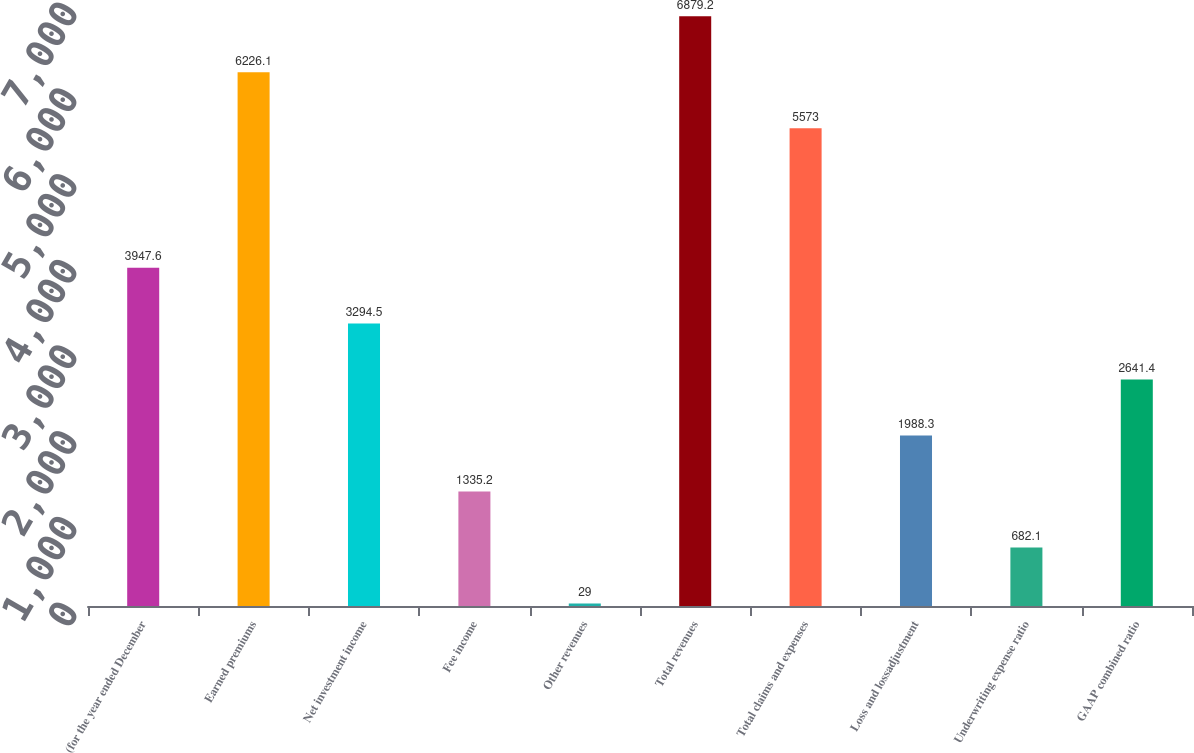Convert chart. <chart><loc_0><loc_0><loc_500><loc_500><bar_chart><fcel>(for the year ended December<fcel>Earned premiums<fcel>Net investment income<fcel>Fee income<fcel>Other revenues<fcel>Total revenues<fcel>Total claims and expenses<fcel>Loss and lossadjustment<fcel>Underwriting expense ratio<fcel>GAAP combined ratio<nl><fcel>3947.6<fcel>6226.1<fcel>3294.5<fcel>1335.2<fcel>29<fcel>6879.2<fcel>5573<fcel>1988.3<fcel>682.1<fcel>2641.4<nl></chart> 